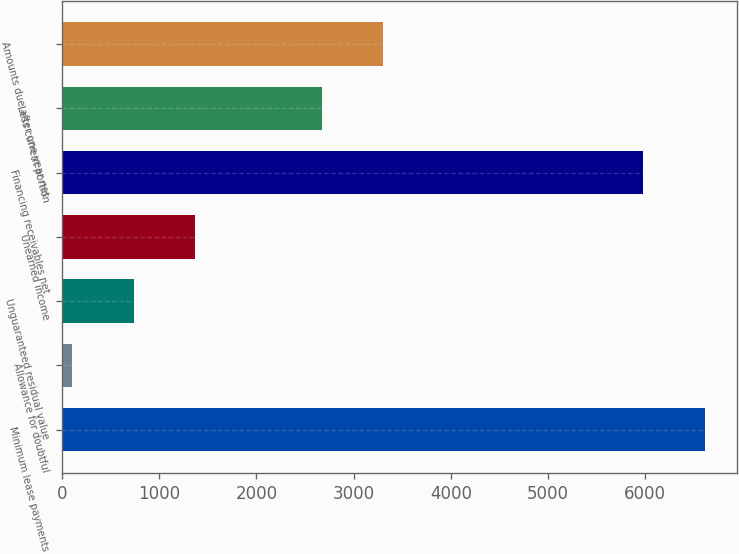Convert chart. <chart><loc_0><loc_0><loc_500><loc_500><bar_chart><fcel>Minimum lease payments<fcel>Allowance for doubtful<fcel>Unguaranteed residual value<fcel>Unearned income<fcel>Financing receivables net<fcel>Less current portion<fcel>Amounts due after one year net<nl><fcel>6608.5<fcel>108<fcel>738.5<fcel>1369<fcel>5978<fcel>2675<fcel>3305.5<nl></chart> 